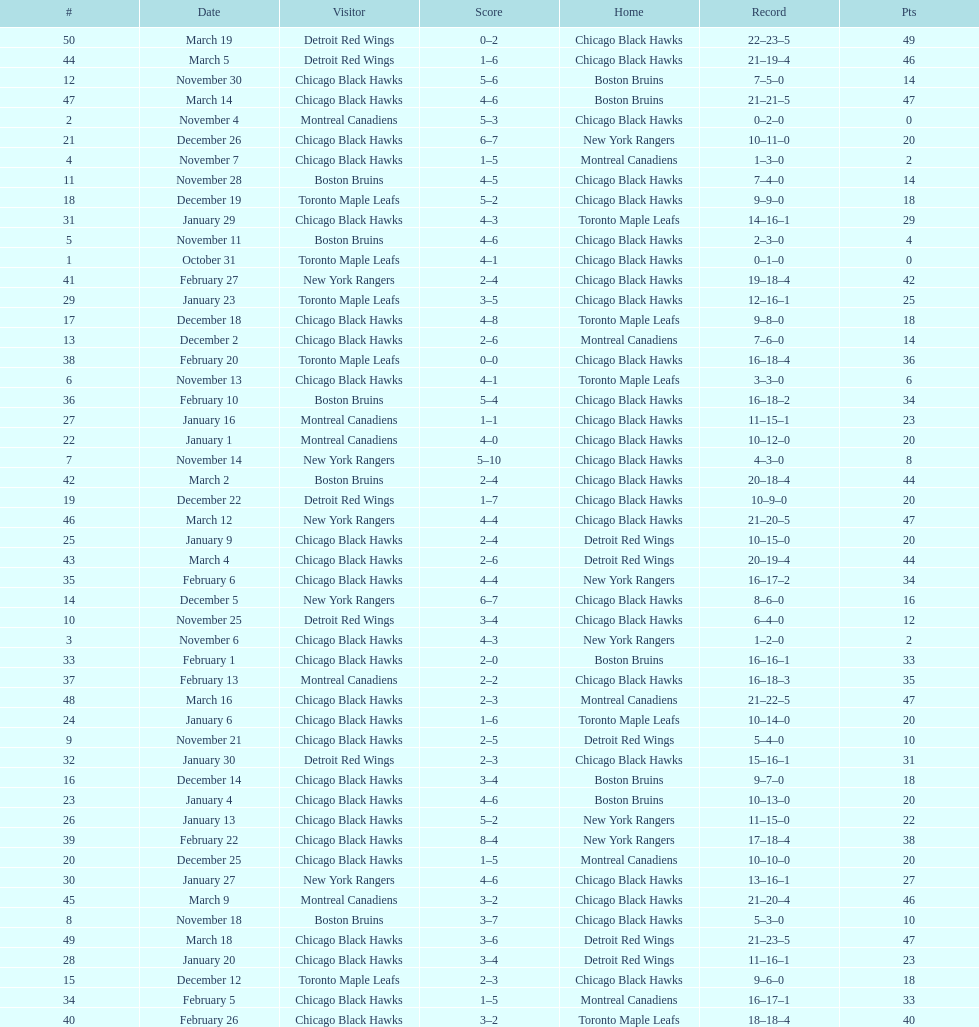Could you help me parse every detail presented in this table? {'header': ['#', 'Date', 'Visitor', 'Score', 'Home', 'Record', 'Pts'], 'rows': [['50', 'March 19', 'Detroit Red Wings', '0–2', 'Chicago Black Hawks', '22–23–5', '49'], ['44', 'March 5', 'Detroit Red Wings', '1–6', 'Chicago Black Hawks', '21–19–4', '46'], ['12', 'November 30', 'Chicago Black Hawks', '5–6', 'Boston Bruins', '7–5–0', '14'], ['47', 'March 14', 'Chicago Black Hawks', '4–6', 'Boston Bruins', '21–21–5', '47'], ['2', 'November 4', 'Montreal Canadiens', '5–3', 'Chicago Black Hawks', '0–2–0', '0'], ['21', 'December 26', 'Chicago Black Hawks', '6–7', 'New York Rangers', '10–11–0', '20'], ['4', 'November 7', 'Chicago Black Hawks', '1–5', 'Montreal Canadiens', '1–3–0', '2'], ['11', 'November 28', 'Boston Bruins', '4–5', 'Chicago Black Hawks', '7–4–0', '14'], ['18', 'December 19', 'Toronto Maple Leafs', '5–2', 'Chicago Black Hawks', '9–9–0', '18'], ['31', 'January 29', 'Chicago Black Hawks', '4–3', 'Toronto Maple Leafs', '14–16–1', '29'], ['5', 'November 11', 'Boston Bruins', '4–6', 'Chicago Black Hawks', '2–3–0', '4'], ['1', 'October 31', 'Toronto Maple Leafs', '4–1', 'Chicago Black Hawks', '0–1–0', '0'], ['41', 'February 27', 'New York Rangers', '2–4', 'Chicago Black Hawks', '19–18–4', '42'], ['29', 'January 23', 'Toronto Maple Leafs', '3–5', 'Chicago Black Hawks', '12–16–1', '25'], ['17', 'December 18', 'Chicago Black Hawks', '4–8', 'Toronto Maple Leafs', '9–8–0', '18'], ['13', 'December 2', 'Chicago Black Hawks', '2–6', 'Montreal Canadiens', '7–6–0', '14'], ['38', 'February 20', 'Toronto Maple Leafs', '0–0', 'Chicago Black Hawks', '16–18–4', '36'], ['6', 'November 13', 'Chicago Black Hawks', '4–1', 'Toronto Maple Leafs', '3–3–0', '6'], ['36', 'February 10', 'Boston Bruins', '5–4', 'Chicago Black Hawks', '16–18–2', '34'], ['27', 'January 16', 'Montreal Canadiens', '1–1', 'Chicago Black Hawks', '11–15–1', '23'], ['22', 'January 1', 'Montreal Canadiens', '4–0', 'Chicago Black Hawks', '10–12–0', '20'], ['7', 'November 14', 'New York Rangers', '5–10', 'Chicago Black Hawks', '4–3–0', '8'], ['42', 'March 2', 'Boston Bruins', '2–4', 'Chicago Black Hawks', '20–18–4', '44'], ['19', 'December 22', 'Detroit Red Wings', '1–7', 'Chicago Black Hawks', '10–9–0', '20'], ['46', 'March 12', 'New York Rangers', '4–4', 'Chicago Black Hawks', '21–20–5', '47'], ['25', 'January 9', 'Chicago Black Hawks', '2–4', 'Detroit Red Wings', '10–15–0', '20'], ['43', 'March 4', 'Chicago Black Hawks', '2–6', 'Detroit Red Wings', '20–19–4', '44'], ['35', 'February 6', 'Chicago Black Hawks', '4–4', 'New York Rangers', '16–17–2', '34'], ['14', 'December 5', 'New York Rangers', '6–7', 'Chicago Black Hawks', '8–6–0', '16'], ['10', 'November 25', 'Detroit Red Wings', '3–4', 'Chicago Black Hawks', '6–4–0', '12'], ['3', 'November 6', 'Chicago Black Hawks', '4–3', 'New York Rangers', '1–2–0', '2'], ['33', 'February 1', 'Chicago Black Hawks', '2–0', 'Boston Bruins', '16–16–1', '33'], ['37', 'February 13', 'Montreal Canadiens', '2–2', 'Chicago Black Hawks', '16–18–3', '35'], ['48', 'March 16', 'Chicago Black Hawks', '2–3', 'Montreal Canadiens', '21–22–5', '47'], ['24', 'January 6', 'Chicago Black Hawks', '1–6', 'Toronto Maple Leafs', '10–14–0', '20'], ['9', 'November 21', 'Chicago Black Hawks', '2–5', 'Detroit Red Wings', '5–4–0', '10'], ['32', 'January 30', 'Detroit Red Wings', '2–3', 'Chicago Black Hawks', '15–16–1', '31'], ['16', 'December 14', 'Chicago Black Hawks', '3–4', 'Boston Bruins', '9–7–0', '18'], ['23', 'January 4', 'Chicago Black Hawks', '4–6', 'Boston Bruins', '10–13–0', '20'], ['26', 'January 13', 'Chicago Black Hawks', '5–2', 'New York Rangers', '11–15–0', '22'], ['39', 'February 22', 'Chicago Black Hawks', '8–4', 'New York Rangers', '17–18–4', '38'], ['20', 'December 25', 'Chicago Black Hawks', '1–5', 'Montreal Canadiens', '10–10–0', '20'], ['30', 'January 27', 'New York Rangers', '4–6', 'Chicago Black Hawks', '13–16–1', '27'], ['45', 'March 9', 'Montreal Canadiens', '3–2', 'Chicago Black Hawks', '21–20–4', '46'], ['8', 'November 18', 'Boston Bruins', '3–7', 'Chicago Black Hawks', '5–3–0', '10'], ['49', 'March 18', 'Chicago Black Hawks', '3–6', 'Detroit Red Wings', '21–23–5', '47'], ['28', 'January 20', 'Chicago Black Hawks', '3–4', 'Detroit Red Wings', '11–16–1', '23'], ['15', 'December 12', 'Toronto Maple Leafs', '2–3', 'Chicago Black Hawks', '9–6–0', '18'], ['34', 'February 5', 'Chicago Black Hawks', '1–5', 'Montreal Canadiens', '16–17–1', '33'], ['40', 'February 26', 'Chicago Black Hawks', '3–2', 'Toronto Maple Leafs', '18–18–4', '40']]} How many total games did they win? 22. 